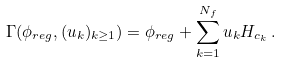Convert formula to latex. <formula><loc_0><loc_0><loc_500><loc_500>\Gamma ( \phi _ { r e g } , ( u _ { k } ) _ { k \geq 1 } ) = \phi _ { r e g } + \sum _ { k = 1 } ^ { N _ { f } } u _ { k } H _ { c _ { k } } \, .</formula> 